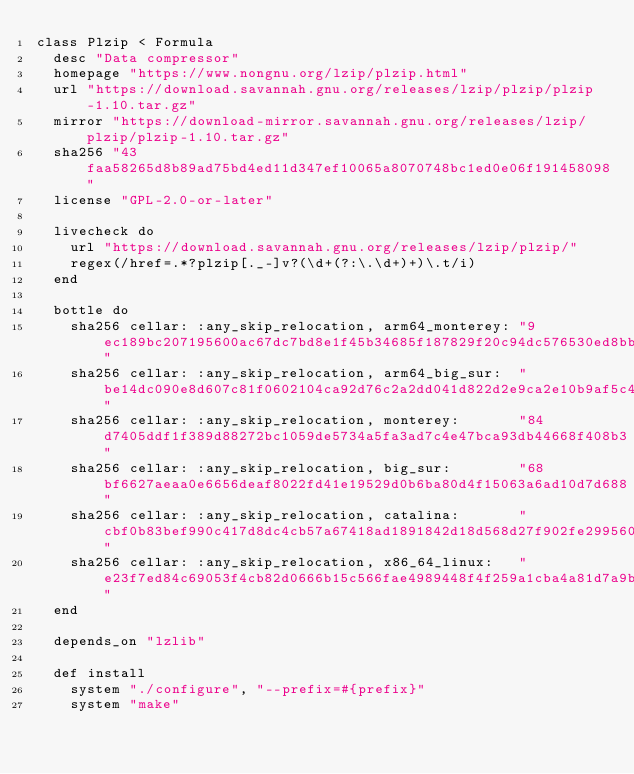Convert code to text. <code><loc_0><loc_0><loc_500><loc_500><_Ruby_>class Plzip < Formula
  desc "Data compressor"
  homepage "https://www.nongnu.org/lzip/plzip.html"
  url "https://download.savannah.gnu.org/releases/lzip/plzip/plzip-1.10.tar.gz"
  mirror "https://download-mirror.savannah.gnu.org/releases/lzip/plzip/plzip-1.10.tar.gz"
  sha256 "43faa58265d8b89ad75bd4ed11d347ef10065a8070748bc1ed0e06f191458098"
  license "GPL-2.0-or-later"

  livecheck do
    url "https://download.savannah.gnu.org/releases/lzip/plzip/"
    regex(/href=.*?plzip[._-]v?(\d+(?:\.\d+)+)\.t/i)
  end

  bottle do
    sha256 cellar: :any_skip_relocation, arm64_monterey: "9ec189bc207195600ac67dc7bd8e1f45b34685f187829f20c94dc576530ed8bb"
    sha256 cellar: :any_skip_relocation, arm64_big_sur:  "be14dc090e8d607c81f0602104ca92d76c2a2dd041d822d2e9ca2e10b9af5c40"
    sha256 cellar: :any_skip_relocation, monterey:       "84d7405ddf1f389d88272bc1059de5734a5fa3ad7c4e47bca93db44668f408b3"
    sha256 cellar: :any_skip_relocation, big_sur:        "68bf6627aeaa0e6656deaf8022fd41e19529d0b6ba80d4f15063a6ad10d7d688"
    sha256 cellar: :any_skip_relocation, catalina:       "cbf0b83bef990c417d8dc4cb57a67418ad1891842d18d568d27f902fe299560e"
    sha256 cellar: :any_skip_relocation, x86_64_linux:   "e23f7ed84c69053f4cb82d0666b15c566fae4989448f4f259a1cba4a81d7a9b0"
  end

  depends_on "lzlib"

  def install
    system "./configure", "--prefix=#{prefix}"
    system "make"</code> 